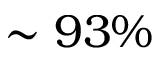<formula> <loc_0><loc_0><loc_500><loc_500>\sim 9 3 \%</formula> 